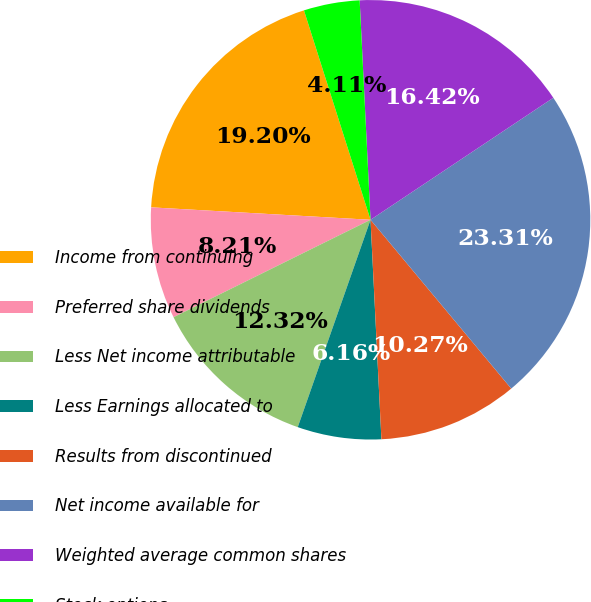Convert chart. <chart><loc_0><loc_0><loc_500><loc_500><pie_chart><fcel>Income from continuing<fcel>Preferred share dividends<fcel>Less Net income attributable<fcel>Less Earnings allocated to<fcel>Results from discontinued<fcel>Net income available for<fcel>Weighted average common shares<fcel>Stock options<nl><fcel>19.2%<fcel>8.21%<fcel>12.32%<fcel>6.16%<fcel>10.27%<fcel>23.31%<fcel>16.42%<fcel>4.11%<nl></chart> 